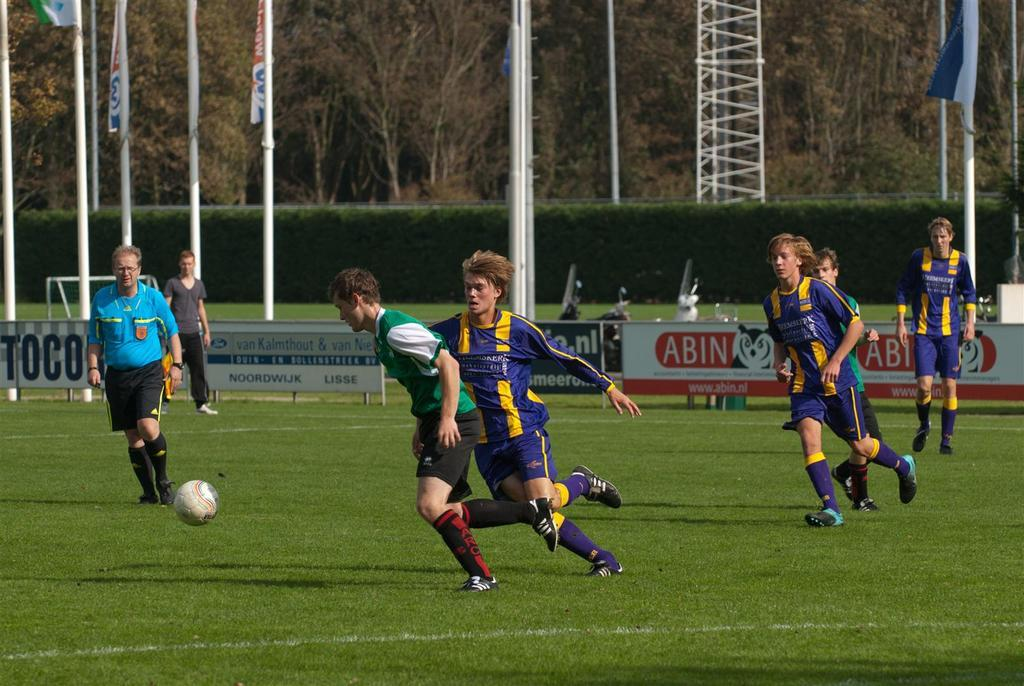How many people are in the image? There is a group of persons in the image, but the exact number cannot be determined from the provided facts. What is on the ground near the persons? There is a ball on the ground near the persons. What can be seen behind the persons? Boards, poles, and vehicles are visible behind the persons, as well as a group of plants and trees. What type of cork can be seen in the image? There is no cork present in the image. What flavor of mint is being consumed by the persons in the image? There is no mention of mint or any food or drink being consumed in the image. 